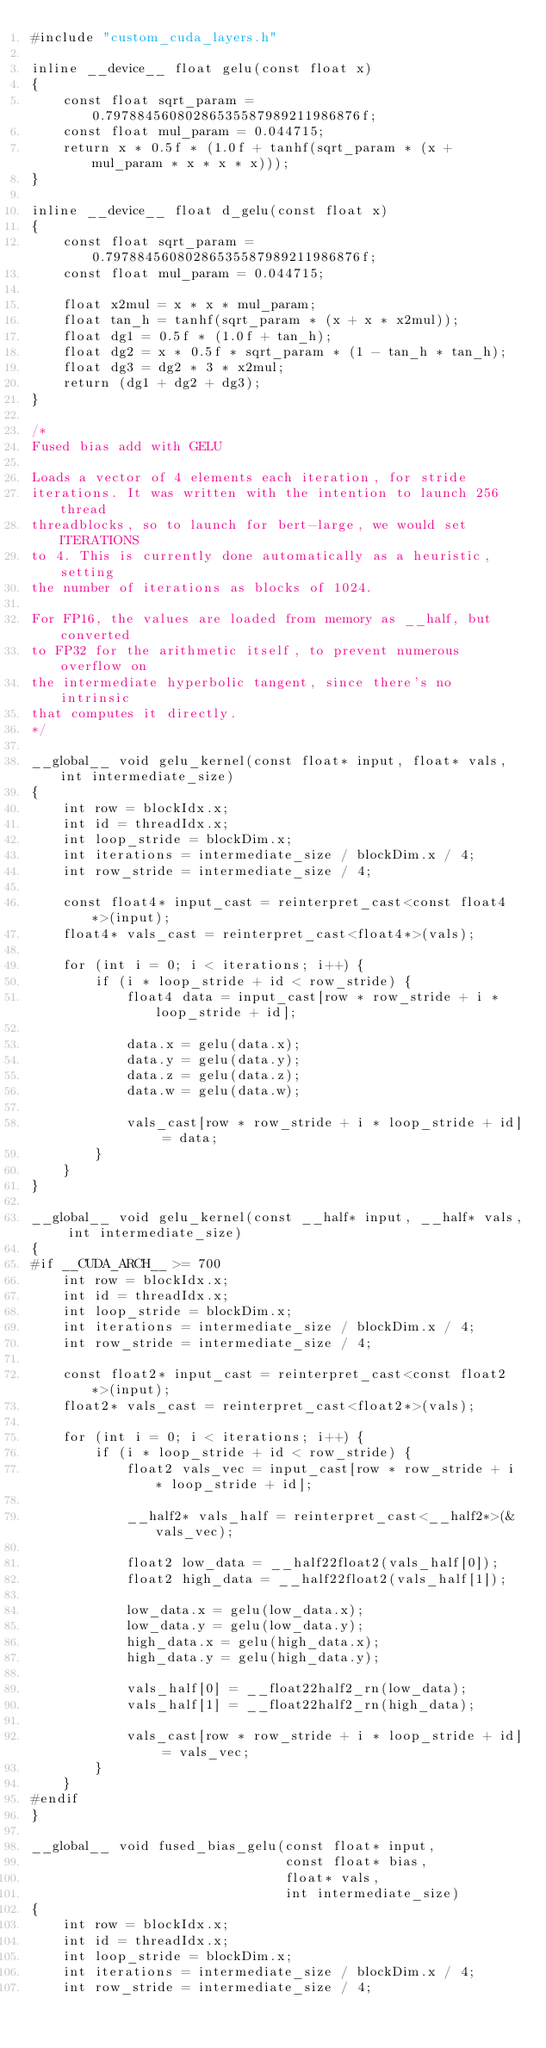Convert code to text. <code><loc_0><loc_0><loc_500><loc_500><_Cuda_>#include "custom_cuda_layers.h"

inline __device__ float gelu(const float x)
{
    const float sqrt_param = 0.79788456080286535587989211986876f;
    const float mul_param = 0.044715;
    return x * 0.5f * (1.0f + tanhf(sqrt_param * (x + mul_param * x * x * x)));
}

inline __device__ float d_gelu(const float x)
{
    const float sqrt_param = 0.79788456080286535587989211986876f;
    const float mul_param = 0.044715;

    float x2mul = x * x * mul_param;
    float tan_h = tanhf(sqrt_param * (x + x * x2mul));
    float dg1 = 0.5f * (1.0f + tan_h);
    float dg2 = x * 0.5f * sqrt_param * (1 - tan_h * tan_h);
    float dg3 = dg2 * 3 * x2mul;
    return (dg1 + dg2 + dg3);
}

/*
Fused bias add with GELU

Loads a vector of 4 elements each iteration, for stride
iterations. It was written with the intention to launch 256 thread
threadblocks, so to launch for bert-large, we would set ITERATIONS
to 4. This is currently done automatically as a heuristic, setting
the number of iterations as blocks of 1024.

For FP16, the values are loaded from memory as __half, but converted
to FP32 for the arithmetic itself, to prevent numerous overflow on
the intermediate hyperbolic tangent, since there's no intrinsic
that computes it directly.
*/

__global__ void gelu_kernel(const float* input, float* vals, int intermediate_size)
{
    int row = blockIdx.x;
    int id = threadIdx.x;
    int loop_stride = blockDim.x;
    int iterations = intermediate_size / blockDim.x / 4;
    int row_stride = intermediate_size / 4;

    const float4* input_cast = reinterpret_cast<const float4*>(input);
    float4* vals_cast = reinterpret_cast<float4*>(vals);

    for (int i = 0; i < iterations; i++) {
        if (i * loop_stride + id < row_stride) {
            float4 data = input_cast[row * row_stride + i * loop_stride + id];

            data.x = gelu(data.x);
            data.y = gelu(data.y);
            data.z = gelu(data.z);
            data.w = gelu(data.w);

            vals_cast[row * row_stride + i * loop_stride + id] = data;
        }
    }
}

__global__ void gelu_kernel(const __half* input, __half* vals, int intermediate_size)
{
#if __CUDA_ARCH__ >= 700
    int row = blockIdx.x;
    int id = threadIdx.x;
    int loop_stride = blockDim.x;
    int iterations = intermediate_size / blockDim.x / 4;
    int row_stride = intermediate_size / 4;

    const float2* input_cast = reinterpret_cast<const float2*>(input);
    float2* vals_cast = reinterpret_cast<float2*>(vals);

    for (int i = 0; i < iterations; i++) {
        if (i * loop_stride + id < row_stride) {
            float2 vals_vec = input_cast[row * row_stride + i * loop_stride + id];

            __half2* vals_half = reinterpret_cast<__half2*>(&vals_vec);

            float2 low_data = __half22float2(vals_half[0]);
            float2 high_data = __half22float2(vals_half[1]);

            low_data.x = gelu(low_data.x);
            low_data.y = gelu(low_data.y);
            high_data.x = gelu(high_data.x);
            high_data.y = gelu(high_data.y);

            vals_half[0] = __float22half2_rn(low_data);
            vals_half[1] = __float22half2_rn(high_data);

            vals_cast[row * row_stride + i * loop_stride + id] = vals_vec;
        }
    }
#endif
}

__global__ void fused_bias_gelu(const float* input,
                                const float* bias,
                                float* vals,
                                int intermediate_size)
{
    int row = blockIdx.x;
    int id = threadIdx.x;
    int loop_stride = blockDim.x;
    int iterations = intermediate_size / blockDim.x / 4;
    int row_stride = intermediate_size / 4;
</code> 